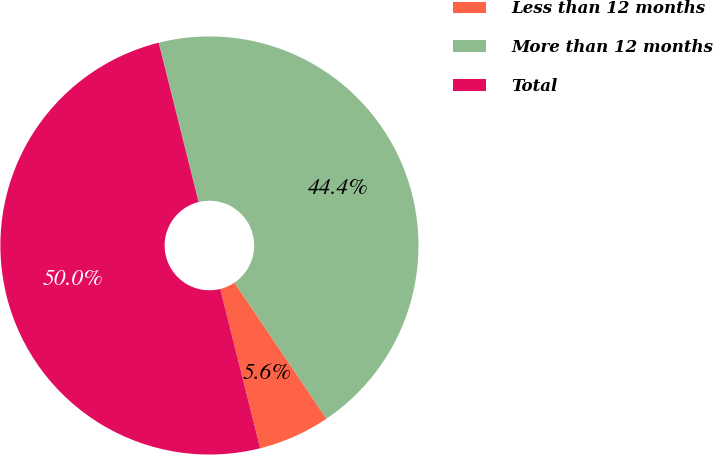<chart> <loc_0><loc_0><loc_500><loc_500><pie_chart><fcel>Less than 12 months<fcel>More than 12 months<fcel>Total<nl><fcel>5.56%<fcel>44.44%<fcel>50.0%<nl></chart> 